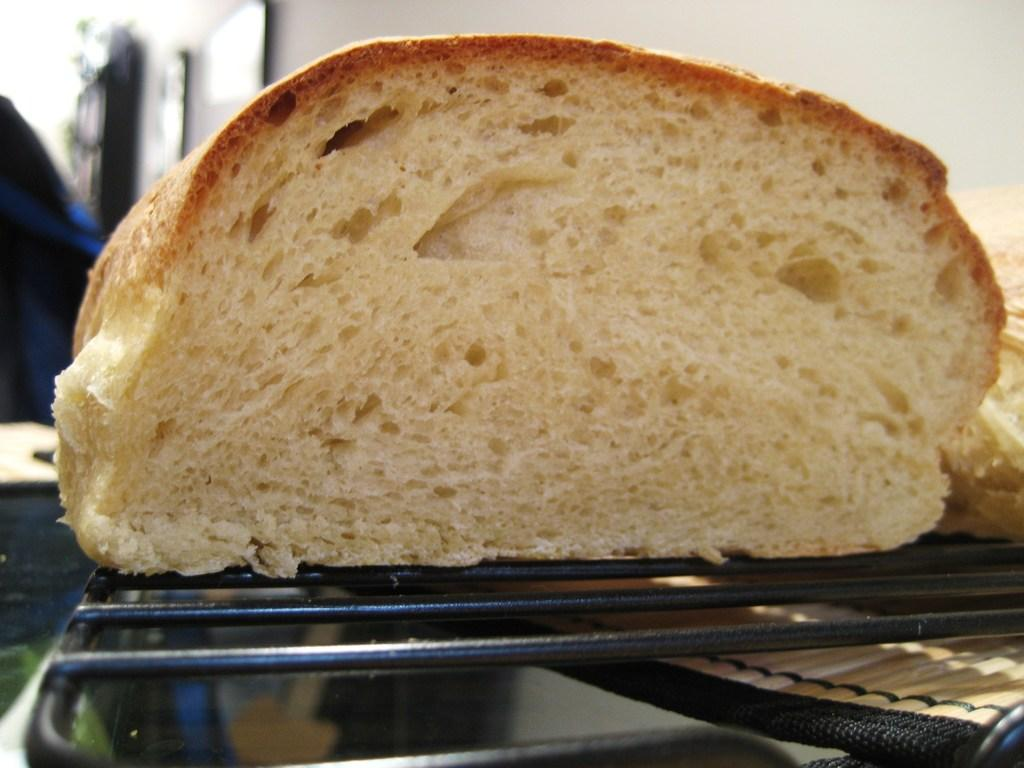What type of food item can be seen in the image? There is a piece of baked item in the image. Where is the baked item located? The baked item is present over a place. How many hours does the volcano erupt in the image? There is no volcano present in the image, so it is not possible to determine how many hours it might erupt. 